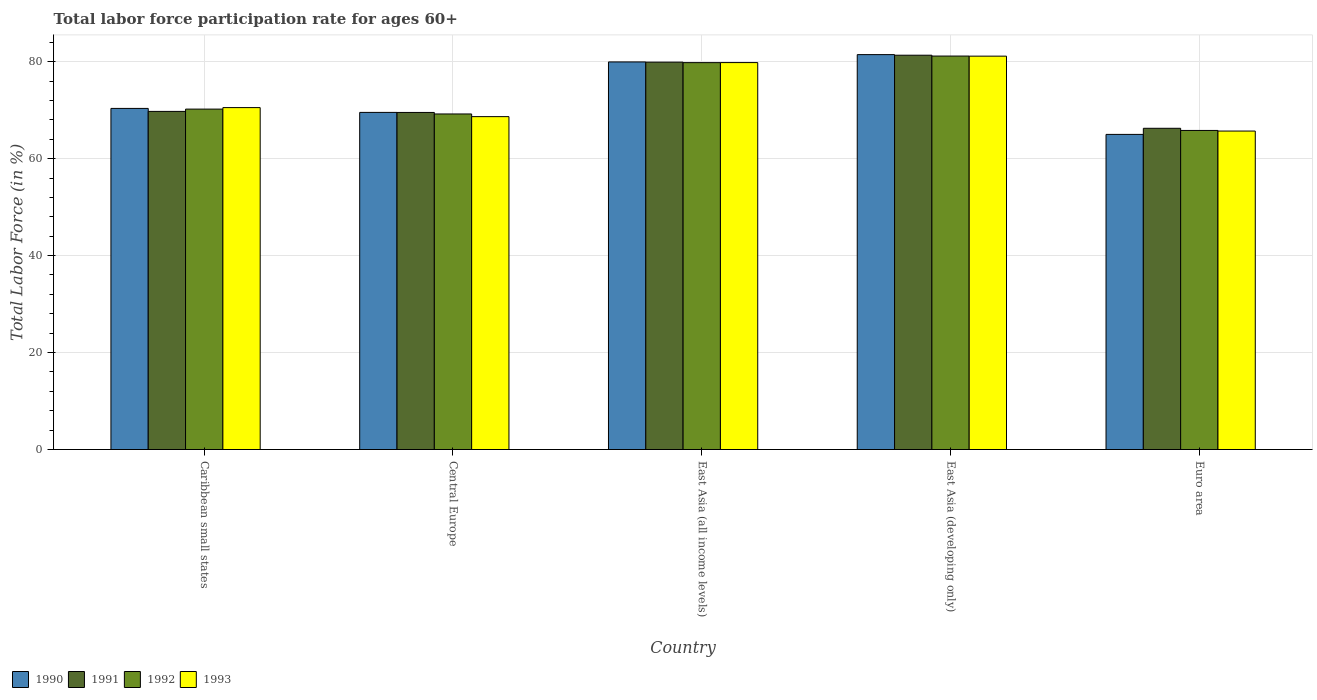How many different coloured bars are there?
Offer a very short reply. 4. How many groups of bars are there?
Make the answer very short. 5. Are the number of bars per tick equal to the number of legend labels?
Keep it short and to the point. Yes. Are the number of bars on each tick of the X-axis equal?
Provide a short and direct response. Yes. How many bars are there on the 3rd tick from the left?
Provide a short and direct response. 4. What is the label of the 5th group of bars from the left?
Provide a short and direct response. Euro area. In how many cases, is the number of bars for a given country not equal to the number of legend labels?
Your answer should be compact. 0. What is the labor force participation rate in 1991 in East Asia (developing only)?
Offer a very short reply. 81.33. Across all countries, what is the maximum labor force participation rate in 1990?
Your answer should be compact. 81.45. Across all countries, what is the minimum labor force participation rate in 1992?
Give a very brief answer. 65.81. In which country was the labor force participation rate in 1993 maximum?
Ensure brevity in your answer.  East Asia (developing only). In which country was the labor force participation rate in 1992 minimum?
Make the answer very short. Euro area. What is the total labor force participation rate in 1990 in the graph?
Provide a succinct answer. 366.29. What is the difference between the labor force participation rate in 1990 in Caribbean small states and that in East Asia (developing only)?
Your answer should be compact. -11.1. What is the difference between the labor force participation rate in 1992 in Central Europe and the labor force participation rate in 1990 in Euro area?
Ensure brevity in your answer.  4.21. What is the average labor force participation rate in 1992 per country?
Provide a short and direct response. 73.24. What is the difference between the labor force participation rate of/in 1993 and labor force participation rate of/in 1990 in East Asia (all income levels)?
Offer a terse response. -0.14. In how many countries, is the labor force participation rate in 1992 greater than 20 %?
Your response must be concise. 5. What is the ratio of the labor force participation rate in 1991 in Caribbean small states to that in Central Europe?
Make the answer very short. 1. What is the difference between the highest and the second highest labor force participation rate in 1993?
Your answer should be very brief. 10.61. What is the difference between the highest and the lowest labor force participation rate in 1992?
Keep it short and to the point. 15.34. In how many countries, is the labor force participation rate in 1993 greater than the average labor force participation rate in 1993 taken over all countries?
Keep it short and to the point. 2. Are all the bars in the graph horizontal?
Provide a succinct answer. No. What is the difference between two consecutive major ticks on the Y-axis?
Offer a very short reply. 20. Does the graph contain any zero values?
Offer a terse response. No. Does the graph contain grids?
Give a very brief answer. Yes. Where does the legend appear in the graph?
Keep it short and to the point. Bottom left. How many legend labels are there?
Ensure brevity in your answer.  4. What is the title of the graph?
Make the answer very short. Total labor force participation rate for ages 60+. Does "2003" appear as one of the legend labels in the graph?
Your response must be concise. No. What is the Total Labor Force (in %) of 1990 in Caribbean small states?
Make the answer very short. 70.36. What is the Total Labor Force (in %) of 1991 in Caribbean small states?
Provide a short and direct response. 69.74. What is the Total Labor Force (in %) in 1992 in Caribbean small states?
Your answer should be very brief. 70.21. What is the Total Labor Force (in %) of 1993 in Caribbean small states?
Give a very brief answer. 70.53. What is the Total Labor Force (in %) in 1990 in Central Europe?
Give a very brief answer. 69.54. What is the Total Labor Force (in %) of 1991 in Central Europe?
Your response must be concise. 69.52. What is the Total Labor Force (in %) in 1992 in Central Europe?
Give a very brief answer. 69.21. What is the Total Labor Force (in %) in 1993 in Central Europe?
Your answer should be very brief. 68.66. What is the Total Labor Force (in %) in 1990 in East Asia (all income levels)?
Keep it short and to the point. 79.95. What is the Total Labor Force (in %) in 1991 in East Asia (all income levels)?
Keep it short and to the point. 79.9. What is the Total Labor Force (in %) in 1992 in East Asia (all income levels)?
Provide a short and direct response. 79.8. What is the Total Labor Force (in %) in 1993 in East Asia (all income levels)?
Keep it short and to the point. 79.81. What is the Total Labor Force (in %) of 1990 in East Asia (developing only)?
Offer a very short reply. 81.45. What is the Total Labor Force (in %) in 1991 in East Asia (developing only)?
Your response must be concise. 81.33. What is the Total Labor Force (in %) in 1992 in East Asia (developing only)?
Make the answer very short. 81.16. What is the Total Labor Force (in %) of 1993 in East Asia (developing only)?
Ensure brevity in your answer.  81.14. What is the Total Labor Force (in %) in 1990 in Euro area?
Provide a short and direct response. 65. What is the Total Labor Force (in %) of 1991 in Euro area?
Offer a very short reply. 66.26. What is the Total Labor Force (in %) in 1992 in Euro area?
Keep it short and to the point. 65.81. What is the Total Labor Force (in %) in 1993 in Euro area?
Provide a succinct answer. 65.69. Across all countries, what is the maximum Total Labor Force (in %) of 1990?
Your answer should be very brief. 81.45. Across all countries, what is the maximum Total Labor Force (in %) of 1991?
Provide a succinct answer. 81.33. Across all countries, what is the maximum Total Labor Force (in %) of 1992?
Your response must be concise. 81.16. Across all countries, what is the maximum Total Labor Force (in %) of 1993?
Your answer should be very brief. 81.14. Across all countries, what is the minimum Total Labor Force (in %) in 1990?
Your response must be concise. 65. Across all countries, what is the minimum Total Labor Force (in %) of 1991?
Your answer should be very brief. 66.26. Across all countries, what is the minimum Total Labor Force (in %) of 1992?
Give a very brief answer. 65.81. Across all countries, what is the minimum Total Labor Force (in %) in 1993?
Your response must be concise. 65.69. What is the total Total Labor Force (in %) in 1990 in the graph?
Your answer should be very brief. 366.29. What is the total Total Labor Force (in %) of 1991 in the graph?
Make the answer very short. 366.76. What is the total Total Labor Force (in %) in 1992 in the graph?
Keep it short and to the point. 366.2. What is the total Total Labor Force (in %) of 1993 in the graph?
Make the answer very short. 365.82. What is the difference between the Total Labor Force (in %) of 1990 in Caribbean small states and that in Central Europe?
Your answer should be very brief. 0.82. What is the difference between the Total Labor Force (in %) of 1991 in Caribbean small states and that in Central Europe?
Your answer should be compact. 0.22. What is the difference between the Total Labor Force (in %) of 1992 in Caribbean small states and that in Central Europe?
Your answer should be very brief. 1. What is the difference between the Total Labor Force (in %) of 1993 in Caribbean small states and that in Central Europe?
Ensure brevity in your answer.  1.86. What is the difference between the Total Labor Force (in %) in 1990 in Caribbean small states and that in East Asia (all income levels)?
Provide a short and direct response. -9.59. What is the difference between the Total Labor Force (in %) of 1991 in Caribbean small states and that in East Asia (all income levels)?
Offer a very short reply. -10.16. What is the difference between the Total Labor Force (in %) of 1992 in Caribbean small states and that in East Asia (all income levels)?
Provide a succinct answer. -9.59. What is the difference between the Total Labor Force (in %) of 1993 in Caribbean small states and that in East Asia (all income levels)?
Keep it short and to the point. -9.28. What is the difference between the Total Labor Force (in %) in 1990 in Caribbean small states and that in East Asia (developing only)?
Your answer should be compact. -11.1. What is the difference between the Total Labor Force (in %) of 1991 in Caribbean small states and that in East Asia (developing only)?
Provide a succinct answer. -11.59. What is the difference between the Total Labor Force (in %) in 1992 in Caribbean small states and that in East Asia (developing only)?
Ensure brevity in your answer.  -10.94. What is the difference between the Total Labor Force (in %) in 1993 in Caribbean small states and that in East Asia (developing only)?
Make the answer very short. -10.61. What is the difference between the Total Labor Force (in %) of 1990 in Caribbean small states and that in Euro area?
Give a very brief answer. 5.36. What is the difference between the Total Labor Force (in %) of 1991 in Caribbean small states and that in Euro area?
Your answer should be compact. 3.48. What is the difference between the Total Labor Force (in %) in 1992 in Caribbean small states and that in Euro area?
Keep it short and to the point. 4.4. What is the difference between the Total Labor Force (in %) of 1993 in Caribbean small states and that in Euro area?
Offer a terse response. 4.84. What is the difference between the Total Labor Force (in %) of 1990 in Central Europe and that in East Asia (all income levels)?
Offer a very short reply. -10.41. What is the difference between the Total Labor Force (in %) in 1991 in Central Europe and that in East Asia (all income levels)?
Give a very brief answer. -10.38. What is the difference between the Total Labor Force (in %) of 1992 in Central Europe and that in East Asia (all income levels)?
Offer a very short reply. -10.59. What is the difference between the Total Labor Force (in %) of 1993 in Central Europe and that in East Asia (all income levels)?
Your response must be concise. -11.15. What is the difference between the Total Labor Force (in %) of 1990 in Central Europe and that in East Asia (developing only)?
Ensure brevity in your answer.  -11.92. What is the difference between the Total Labor Force (in %) in 1991 in Central Europe and that in East Asia (developing only)?
Your answer should be very brief. -11.81. What is the difference between the Total Labor Force (in %) in 1992 in Central Europe and that in East Asia (developing only)?
Make the answer very short. -11.95. What is the difference between the Total Labor Force (in %) of 1993 in Central Europe and that in East Asia (developing only)?
Give a very brief answer. -12.48. What is the difference between the Total Labor Force (in %) of 1990 in Central Europe and that in Euro area?
Provide a succinct answer. 4.54. What is the difference between the Total Labor Force (in %) of 1991 in Central Europe and that in Euro area?
Your response must be concise. 3.27. What is the difference between the Total Labor Force (in %) of 1992 in Central Europe and that in Euro area?
Ensure brevity in your answer.  3.4. What is the difference between the Total Labor Force (in %) of 1993 in Central Europe and that in Euro area?
Make the answer very short. 2.98. What is the difference between the Total Labor Force (in %) in 1990 in East Asia (all income levels) and that in East Asia (developing only)?
Give a very brief answer. -1.51. What is the difference between the Total Labor Force (in %) in 1991 in East Asia (all income levels) and that in East Asia (developing only)?
Give a very brief answer. -1.43. What is the difference between the Total Labor Force (in %) of 1992 in East Asia (all income levels) and that in East Asia (developing only)?
Ensure brevity in your answer.  -1.36. What is the difference between the Total Labor Force (in %) in 1993 in East Asia (all income levels) and that in East Asia (developing only)?
Your answer should be compact. -1.33. What is the difference between the Total Labor Force (in %) of 1990 in East Asia (all income levels) and that in Euro area?
Your answer should be very brief. 14.95. What is the difference between the Total Labor Force (in %) of 1991 in East Asia (all income levels) and that in Euro area?
Make the answer very short. 13.64. What is the difference between the Total Labor Force (in %) in 1992 in East Asia (all income levels) and that in Euro area?
Give a very brief answer. 13.99. What is the difference between the Total Labor Force (in %) of 1993 in East Asia (all income levels) and that in Euro area?
Offer a very short reply. 14.12. What is the difference between the Total Labor Force (in %) in 1990 in East Asia (developing only) and that in Euro area?
Your answer should be very brief. 16.45. What is the difference between the Total Labor Force (in %) in 1991 in East Asia (developing only) and that in Euro area?
Offer a terse response. 15.07. What is the difference between the Total Labor Force (in %) in 1992 in East Asia (developing only) and that in Euro area?
Make the answer very short. 15.34. What is the difference between the Total Labor Force (in %) in 1993 in East Asia (developing only) and that in Euro area?
Provide a succinct answer. 15.45. What is the difference between the Total Labor Force (in %) in 1990 in Caribbean small states and the Total Labor Force (in %) in 1991 in Central Europe?
Ensure brevity in your answer.  0.83. What is the difference between the Total Labor Force (in %) of 1990 in Caribbean small states and the Total Labor Force (in %) of 1992 in Central Europe?
Your answer should be compact. 1.15. What is the difference between the Total Labor Force (in %) in 1990 in Caribbean small states and the Total Labor Force (in %) in 1993 in Central Europe?
Provide a short and direct response. 1.7. What is the difference between the Total Labor Force (in %) in 1991 in Caribbean small states and the Total Labor Force (in %) in 1992 in Central Europe?
Make the answer very short. 0.53. What is the difference between the Total Labor Force (in %) of 1991 in Caribbean small states and the Total Labor Force (in %) of 1993 in Central Europe?
Give a very brief answer. 1.08. What is the difference between the Total Labor Force (in %) in 1992 in Caribbean small states and the Total Labor Force (in %) in 1993 in Central Europe?
Your answer should be compact. 1.55. What is the difference between the Total Labor Force (in %) in 1990 in Caribbean small states and the Total Labor Force (in %) in 1991 in East Asia (all income levels)?
Your response must be concise. -9.54. What is the difference between the Total Labor Force (in %) of 1990 in Caribbean small states and the Total Labor Force (in %) of 1992 in East Asia (all income levels)?
Your answer should be compact. -9.44. What is the difference between the Total Labor Force (in %) of 1990 in Caribbean small states and the Total Labor Force (in %) of 1993 in East Asia (all income levels)?
Give a very brief answer. -9.45. What is the difference between the Total Labor Force (in %) in 1991 in Caribbean small states and the Total Labor Force (in %) in 1992 in East Asia (all income levels)?
Keep it short and to the point. -10.06. What is the difference between the Total Labor Force (in %) in 1991 in Caribbean small states and the Total Labor Force (in %) in 1993 in East Asia (all income levels)?
Make the answer very short. -10.07. What is the difference between the Total Labor Force (in %) of 1992 in Caribbean small states and the Total Labor Force (in %) of 1993 in East Asia (all income levels)?
Your answer should be very brief. -9.6. What is the difference between the Total Labor Force (in %) of 1990 in Caribbean small states and the Total Labor Force (in %) of 1991 in East Asia (developing only)?
Ensure brevity in your answer.  -10.97. What is the difference between the Total Labor Force (in %) of 1990 in Caribbean small states and the Total Labor Force (in %) of 1992 in East Asia (developing only)?
Give a very brief answer. -10.8. What is the difference between the Total Labor Force (in %) of 1990 in Caribbean small states and the Total Labor Force (in %) of 1993 in East Asia (developing only)?
Provide a succinct answer. -10.78. What is the difference between the Total Labor Force (in %) in 1991 in Caribbean small states and the Total Labor Force (in %) in 1992 in East Asia (developing only)?
Give a very brief answer. -11.42. What is the difference between the Total Labor Force (in %) of 1991 in Caribbean small states and the Total Labor Force (in %) of 1993 in East Asia (developing only)?
Give a very brief answer. -11.4. What is the difference between the Total Labor Force (in %) of 1992 in Caribbean small states and the Total Labor Force (in %) of 1993 in East Asia (developing only)?
Offer a very short reply. -10.92. What is the difference between the Total Labor Force (in %) of 1990 in Caribbean small states and the Total Labor Force (in %) of 1991 in Euro area?
Give a very brief answer. 4.1. What is the difference between the Total Labor Force (in %) of 1990 in Caribbean small states and the Total Labor Force (in %) of 1992 in Euro area?
Your answer should be very brief. 4.55. What is the difference between the Total Labor Force (in %) in 1990 in Caribbean small states and the Total Labor Force (in %) in 1993 in Euro area?
Offer a terse response. 4.67. What is the difference between the Total Labor Force (in %) of 1991 in Caribbean small states and the Total Labor Force (in %) of 1992 in Euro area?
Your answer should be compact. 3.93. What is the difference between the Total Labor Force (in %) of 1991 in Caribbean small states and the Total Labor Force (in %) of 1993 in Euro area?
Offer a terse response. 4.06. What is the difference between the Total Labor Force (in %) in 1992 in Caribbean small states and the Total Labor Force (in %) in 1993 in Euro area?
Give a very brief answer. 4.53. What is the difference between the Total Labor Force (in %) in 1990 in Central Europe and the Total Labor Force (in %) in 1991 in East Asia (all income levels)?
Your answer should be compact. -10.37. What is the difference between the Total Labor Force (in %) of 1990 in Central Europe and the Total Labor Force (in %) of 1992 in East Asia (all income levels)?
Provide a succinct answer. -10.27. What is the difference between the Total Labor Force (in %) in 1990 in Central Europe and the Total Labor Force (in %) in 1993 in East Asia (all income levels)?
Provide a short and direct response. -10.27. What is the difference between the Total Labor Force (in %) of 1991 in Central Europe and the Total Labor Force (in %) of 1992 in East Asia (all income levels)?
Provide a succinct answer. -10.28. What is the difference between the Total Labor Force (in %) of 1991 in Central Europe and the Total Labor Force (in %) of 1993 in East Asia (all income levels)?
Provide a succinct answer. -10.28. What is the difference between the Total Labor Force (in %) in 1992 in Central Europe and the Total Labor Force (in %) in 1993 in East Asia (all income levels)?
Offer a very short reply. -10.6. What is the difference between the Total Labor Force (in %) of 1990 in Central Europe and the Total Labor Force (in %) of 1991 in East Asia (developing only)?
Provide a succinct answer. -11.8. What is the difference between the Total Labor Force (in %) of 1990 in Central Europe and the Total Labor Force (in %) of 1992 in East Asia (developing only)?
Make the answer very short. -11.62. What is the difference between the Total Labor Force (in %) of 1990 in Central Europe and the Total Labor Force (in %) of 1993 in East Asia (developing only)?
Your answer should be compact. -11.6. What is the difference between the Total Labor Force (in %) in 1991 in Central Europe and the Total Labor Force (in %) in 1992 in East Asia (developing only)?
Your response must be concise. -11.63. What is the difference between the Total Labor Force (in %) in 1991 in Central Europe and the Total Labor Force (in %) in 1993 in East Asia (developing only)?
Offer a terse response. -11.61. What is the difference between the Total Labor Force (in %) of 1992 in Central Europe and the Total Labor Force (in %) of 1993 in East Asia (developing only)?
Your answer should be very brief. -11.93. What is the difference between the Total Labor Force (in %) in 1990 in Central Europe and the Total Labor Force (in %) in 1991 in Euro area?
Ensure brevity in your answer.  3.28. What is the difference between the Total Labor Force (in %) in 1990 in Central Europe and the Total Labor Force (in %) in 1992 in Euro area?
Your answer should be very brief. 3.72. What is the difference between the Total Labor Force (in %) in 1990 in Central Europe and the Total Labor Force (in %) in 1993 in Euro area?
Give a very brief answer. 3.85. What is the difference between the Total Labor Force (in %) of 1991 in Central Europe and the Total Labor Force (in %) of 1992 in Euro area?
Offer a terse response. 3.71. What is the difference between the Total Labor Force (in %) in 1991 in Central Europe and the Total Labor Force (in %) in 1993 in Euro area?
Keep it short and to the point. 3.84. What is the difference between the Total Labor Force (in %) of 1992 in Central Europe and the Total Labor Force (in %) of 1993 in Euro area?
Keep it short and to the point. 3.53. What is the difference between the Total Labor Force (in %) of 1990 in East Asia (all income levels) and the Total Labor Force (in %) of 1991 in East Asia (developing only)?
Your answer should be very brief. -1.39. What is the difference between the Total Labor Force (in %) in 1990 in East Asia (all income levels) and the Total Labor Force (in %) in 1992 in East Asia (developing only)?
Your response must be concise. -1.21. What is the difference between the Total Labor Force (in %) in 1990 in East Asia (all income levels) and the Total Labor Force (in %) in 1993 in East Asia (developing only)?
Your response must be concise. -1.19. What is the difference between the Total Labor Force (in %) in 1991 in East Asia (all income levels) and the Total Labor Force (in %) in 1992 in East Asia (developing only)?
Ensure brevity in your answer.  -1.26. What is the difference between the Total Labor Force (in %) in 1991 in East Asia (all income levels) and the Total Labor Force (in %) in 1993 in East Asia (developing only)?
Ensure brevity in your answer.  -1.24. What is the difference between the Total Labor Force (in %) in 1992 in East Asia (all income levels) and the Total Labor Force (in %) in 1993 in East Asia (developing only)?
Ensure brevity in your answer.  -1.34. What is the difference between the Total Labor Force (in %) of 1990 in East Asia (all income levels) and the Total Labor Force (in %) of 1991 in Euro area?
Offer a terse response. 13.69. What is the difference between the Total Labor Force (in %) in 1990 in East Asia (all income levels) and the Total Labor Force (in %) in 1992 in Euro area?
Your response must be concise. 14.13. What is the difference between the Total Labor Force (in %) in 1990 in East Asia (all income levels) and the Total Labor Force (in %) in 1993 in Euro area?
Give a very brief answer. 14.26. What is the difference between the Total Labor Force (in %) of 1991 in East Asia (all income levels) and the Total Labor Force (in %) of 1992 in Euro area?
Offer a very short reply. 14.09. What is the difference between the Total Labor Force (in %) of 1991 in East Asia (all income levels) and the Total Labor Force (in %) of 1993 in Euro area?
Provide a succinct answer. 14.22. What is the difference between the Total Labor Force (in %) of 1992 in East Asia (all income levels) and the Total Labor Force (in %) of 1993 in Euro area?
Ensure brevity in your answer.  14.12. What is the difference between the Total Labor Force (in %) in 1990 in East Asia (developing only) and the Total Labor Force (in %) in 1991 in Euro area?
Make the answer very short. 15.19. What is the difference between the Total Labor Force (in %) in 1990 in East Asia (developing only) and the Total Labor Force (in %) in 1992 in Euro area?
Your response must be concise. 15.64. What is the difference between the Total Labor Force (in %) of 1990 in East Asia (developing only) and the Total Labor Force (in %) of 1993 in Euro area?
Your answer should be compact. 15.77. What is the difference between the Total Labor Force (in %) of 1991 in East Asia (developing only) and the Total Labor Force (in %) of 1992 in Euro area?
Provide a short and direct response. 15.52. What is the difference between the Total Labor Force (in %) in 1991 in East Asia (developing only) and the Total Labor Force (in %) in 1993 in Euro area?
Your answer should be compact. 15.65. What is the difference between the Total Labor Force (in %) in 1992 in East Asia (developing only) and the Total Labor Force (in %) in 1993 in Euro area?
Make the answer very short. 15.47. What is the average Total Labor Force (in %) of 1990 per country?
Your response must be concise. 73.26. What is the average Total Labor Force (in %) in 1991 per country?
Keep it short and to the point. 73.35. What is the average Total Labor Force (in %) of 1992 per country?
Provide a short and direct response. 73.24. What is the average Total Labor Force (in %) in 1993 per country?
Provide a succinct answer. 73.16. What is the difference between the Total Labor Force (in %) in 1990 and Total Labor Force (in %) in 1991 in Caribbean small states?
Give a very brief answer. 0.62. What is the difference between the Total Labor Force (in %) of 1990 and Total Labor Force (in %) of 1992 in Caribbean small states?
Keep it short and to the point. 0.14. What is the difference between the Total Labor Force (in %) of 1990 and Total Labor Force (in %) of 1993 in Caribbean small states?
Make the answer very short. -0.17. What is the difference between the Total Labor Force (in %) of 1991 and Total Labor Force (in %) of 1992 in Caribbean small states?
Offer a very short reply. -0.47. What is the difference between the Total Labor Force (in %) in 1991 and Total Labor Force (in %) in 1993 in Caribbean small states?
Offer a very short reply. -0.78. What is the difference between the Total Labor Force (in %) of 1992 and Total Labor Force (in %) of 1993 in Caribbean small states?
Keep it short and to the point. -0.31. What is the difference between the Total Labor Force (in %) of 1990 and Total Labor Force (in %) of 1991 in Central Europe?
Your answer should be very brief. 0.01. What is the difference between the Total Labor Force (in %) of 1990 and Total Labor Force (in %) of 1992 in Central Europe?
Your response must be concise. 0.32. What is the difference between the Total Labor Force (in %) of 1990 and Total Labor Force (in %) of 1993 in Central Europe?
Provide a short and direct response. 0.87. What is the difference between the Total Labor Force (in %) of 1991 and Total Labor Force (in %) of 1992 in Central Europe?
Provide a succinct answer. 0.31. What is the difference between the Total Labor Force (in %) in 1991 and Total Labor Force (in %) in 1993 in Central Europe?
Your response must be concise. 0.86. What is the difference between the Total Labor Force (in %) of 1992 and Total Labor Force (in %) of 1993 in Central Europe?
Make the answer very short. 0.55. What is the difference between the Total Labor Force (in %) of 1990 and Total Labor Force (in %) of 1991 in East Asia (all income levels)?
Make the answer very short. 0.04. What is the difference between the Total Labor Force (in %) in 1990 and Total Labor Force (in %) in 1992 in East Asia (all income levels)?
Your answer should be very brief. 0.14. What is the difference between the Total Labor Force (in %) of 1990 and Total Labor Force (in %) of 1993 in East Asia (all income levels)?
Offer a very short reply. 0.14. What is the difference between the Total Labor Force (in %) of 1991 and Total Labor Force (in %) of 1992 in East Asia (all income levels)?
Your response must be concise. 0.1. What is the difference between the Total Labor Force (in %) in 1991 and Total Labor Force (in %) in 1993 in East Asia (all income levels)?
Keep it short and to the point. 0.09. What is the difference between the Total Labor Force (in %) of 1992 and Total Labor Force (in %) of 1993 in East Asia (all income levels)?
Keep it short and to the point. -0.01. What is the difference between the Total Labor Force (in %) in 1990 and Total Labor Force (in %) in 1991 in East Asia (developing only)?
Give a very brief answer. 0.12. What is the difference between the Total Labor Force (in %) in 1990 and Total Labor Force (in %) in 1992 in East Asia (developing only)?
Provide a succinct answer. 0.3. What is the difference between the Total Labor Force (in %) in 1990 and Total Labor Force (in %) in 1993 in East Asia (developing only)?
Keep it short and to the point. 0.32. What is the difference between the Total Labor Force (in %) of 1991 and Total Labor Force (in %) of 1992 in East Asia (developing only)?
Offer a very short reply. 0.17. What is the difference between the Total Labor Force (in %) of 1991 and Total Labor Force (in %) of 1993 in East Asia (developing only)?
Keep it short and to the point. 0.19. What is the difference between the Total Labor Force (in %) in 1992 and Total Labor Force (in %) in 1993 in East Asia (developing only)?
Keep it short and to the point. 0.02. What is the difference between the Total Labor Force (in %) of 1990 and Total Labor Force (in %) of 1991 in Euro area?
Ensure brevity in your answer.  -1.26. What is the difference between the Total Labor Force (in %) of 1990 and Total Labor Force (in %) of 1992 in Euro area?
Offer a very short reply. -0.81. What is the difference between the Total Labor Force (in %) of 1990 and Total Labor Force (in %) of 1993 in Euro area?
Offer a very short reply. -0.69. What is the difference between the Total Labor Force (in %) in 1991 and Total Labor Force (in %) in 1992 in Euro area?
Ensure brevity in your answer.  0.45. What is the difference between the Total Labor Force (in %) of 1991 and Total Labor Force (in %) of 1993 in Euro area?
Make the answer very short. 0.57. What is the difference between the Total Labor Force (in %) in 1992 and Total Labor Force (in %) in 1993 in Euro area?
Keep it short and to the point. 0.13. What is the ratio of the Total Labor Force (in %) in 1990 in Caribbean small states to that in Central Europe?
Provide a succinct answer. 1.01. What is the ratio of the Total Labor Force (in %) of 1991 in Caribbean small states to that in Central Europe?
Ensure brevity in your answer.  1. What is the ratio of the Total Labor Force (in %) in 1992 in Caribbean small states to that in Central Europe?
Offer a very short reply. 1.01. What is the ratio of the Total Labor Force (in %) of 1993 in Caribbean small states to that in Central Europe?
Keep it short and to the point. 1.03. What is the ratio of the Total Labor Force (in %) of 1990 in Caribbean small states to that in East Asia (all income levels)?
Ensure brevity in your answer.  0.88. What is the ratio of the Total Labor Force (in %) in 1991 in Caribbean small states to that in East Asia (all income levels)?
Your response must be concise. 0.87. What is the ratio of the Total Labor Force (in %) of 1992 in Caribbean small states to that in East Asia (all income levels)?
Make the answer very short. 0.88. What is the ratio of the Total Labor Force (in %) in 1993 in Caribbean small states to that in East Asia (all income levels)?
Keep it short and to the point. 0.88. What is the ratio of the Total Labor Force (in %) in 1990 in Caribbean small states to that in East Asia (developing only)?
Your answer should be compact. 0.86. What is the ratio of the Total Labor Force (in %) in 1991 in Caribbean small states to that in East Asia (developing only)?
Give a very brief answer. 0.86. What is the ratio of the Total Labor Force (in %) in 1992 in Caribbean small states to that in East Asia (developing only)?
Offer a terse response. 0.87. What is the ratio of the Total Labor Force (in %) of 1993 in Caribbean small states to that in East Asia (developing only)?
Your response must be concise. 0.87. What is the ratio of the Total Labor Force (in %) in 1990 in Caribbean small states to that in Euro area?
Provide a short and direct response. 1.08. What is the ratio of the Total Labor Force (in %) in 1991 in Caribbean small states to that in Euro area?
Your answer should be very brief. 1.05. What is the ratio of the Total Labor Force (in %) of 1992 in Caribbean small states to that in Euro area?
Offer a terse response. 1.07. What is the ratio of the Total Labor Force (in %) of 1993 in Caribbean small states to that in Euro area?
Ensure brevity in your answer.  1.07. What is the ratio of the Total Labor Force (in %) of 1990 in Central Europe to that in East Asia (all income levels)?
Make the answer very short. 0.87. What is the ratio of the Total Labor Force (in %) in 1991 in Central Europe to that in East Asia (all income levels)?
Offer a very short reply. 0.87. What is the ratio of the Total Labor Force (in %) in 1992 in Central Europe to that in East Asia (all income levels)?
Make the answer very short. 0.87. What is the ratio of the Total Labor Force (in %) in 1993 in Central Europe to that in East Asia (all income levels)?
Make the answer very short. 0.86. What is the ratio of the Total Labor Force (in %) of 1990 in Central Europe to that in East Asia (developing only)?
Offer a very short reply. 0.85. What is the ratio of the Total Labor Force (in %) in 1991 in Central Europe to that in East Asia (developing only)?
Offer a very short reply. 0.85. What is the ratio of the Total Labor Force (in %) of 1992 in Central Europe to that in East Asia (developing only)?
Make the answer very short. 0.85. What is the ratio of the Total Labor Force (in %) of 1993 in Central Europe to that in East Asia (developing only)?
Your answer should be very brief. 0.85. What is the ratio of the Total Labor Force (in %) in 1990 in Central Europe to that in Euro area?
Offer a terse response. 1.07. What is the ratio of the Total Labor Force (in %) of 1991 in Central Europe to that in Euro area?
Ensure brevity in your answer.  1.05. What is the ratio of the Total Labor Force (in %) of 1992 in Central Europe to that in Euro area?
Your answer should be compact. 1.05. What is the ratio of the Total Labor Force (in %) in 1993 in Central Europe to that in Euro area?
Provide a short and direct response. 1.05. What is the ratio of the Total Labor Force (in %) of 1990 in East Asia (all income levels) to that in East Asia (developing only)?
Your answer should be very brief. 0.98. What is the ratio of the Total Labor Force (in %) of 1991 in East Asia (all income levels) to that in East Asia (developing only)?
Provide a succinct answer. 0.98. What is the ratio of the Total Labor Force (in %) of 1992 in East Asia (all income levels) to that in East Asia (developing only)?
Offer a very short reply. 0.98. What is the ratio of the Total Labor Force (in %) of 1993 in East Asia (all income levels) to that in East Asia (developing only)?
Provide a succinct answer. 0.98. What is the ratio of the Total Labor Force (in %) in 1990 in East Asia (all income levels) to that in Euro area?
Provide a short and direct response. 1.23. What is the ratio of the Total Labor Force (in %) in 1991 in East Asia (all income levels) to that in Euro area?
Provide a succinct answer. 1.21. What is the ratio of the Total Labor Force (in %) in 1992 in East Asia (all income levels) to that in Euro area?
Provide a succinct answer. 1.21. What is the ratio of the Total Labor Force (in %) of 1993 in East Asia (all income levels) to that in Euro area?
Make the answer very short. 1.22. What is the ratio of the Total Labor Force (in %) in 1990 in East Asia (developing only) to that in Euro area?
Provide a short and direct response. 1.25. What is the ratio of the Total Labor Force (in %) in 1991 in East Asia (developing only) to that in Euro area?
Your answer should be very brief. 1.23. What is the ratio of the Total Labor Force (in %) of 1992 in East Asia (developing only) to that in Euro area?
Keep it short and to the point. 1.23. What is the ratio of the Total Labor Force (in %) of 1993 in East Asia (developing only) to that in Euro area?
Offer a terse response. 1.24. What is the difference between the highest and the second highest Total Labor Force (in %) in 1990?
Your answer should be very brief. 1.51. What is the difference between the highest and the second highest Total Labor Force (in %) of 1991?
Your answer should be very brief. 1.43. What is the difference between the highest and the second highest Total Labor Force (in %) in 1992?
Provide a succinct answer. 1.36. What is the difference between the highest and the second highest Total Labor Force (in %) in 1993?
Your answer should be compact. 1.33. What is the difference between the highest and the lowest Total Labor Force (in %) in 1990?
Provide a succinct answer. 16.45. What is the difference between the highest and the lowest Total Labor Force (in %) of 1991?
Offer a very short reply. 15.07. What is the difference between the highest and the lowest Total Labor Force (in %) of 1992?
Provide a succinct answer. 15.34. What is the difference between the highest and the lowest Total Labor Force (in %) of 1993?
Give a very brief answer. 15.45. 